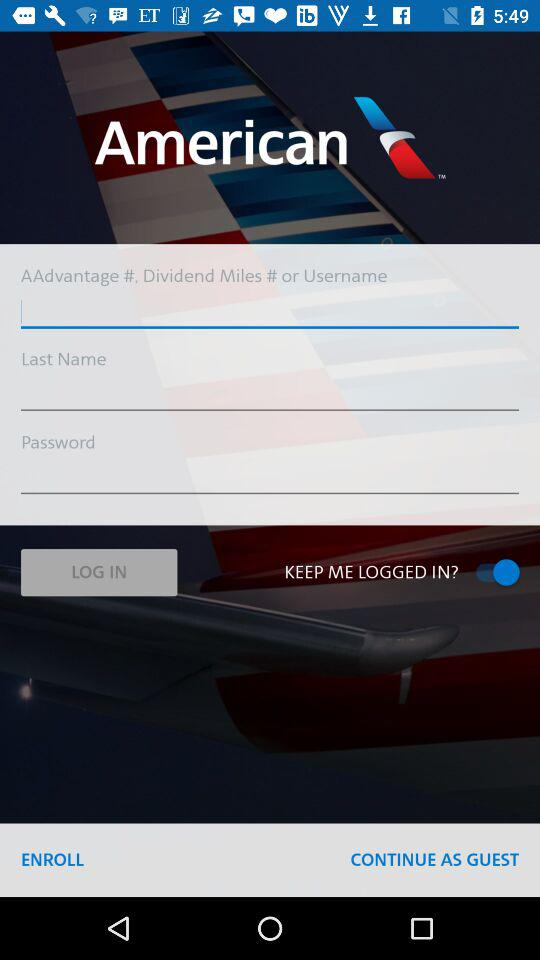How many text fields are there on this login screen?
Answer the question using a single word or phrase. 3 